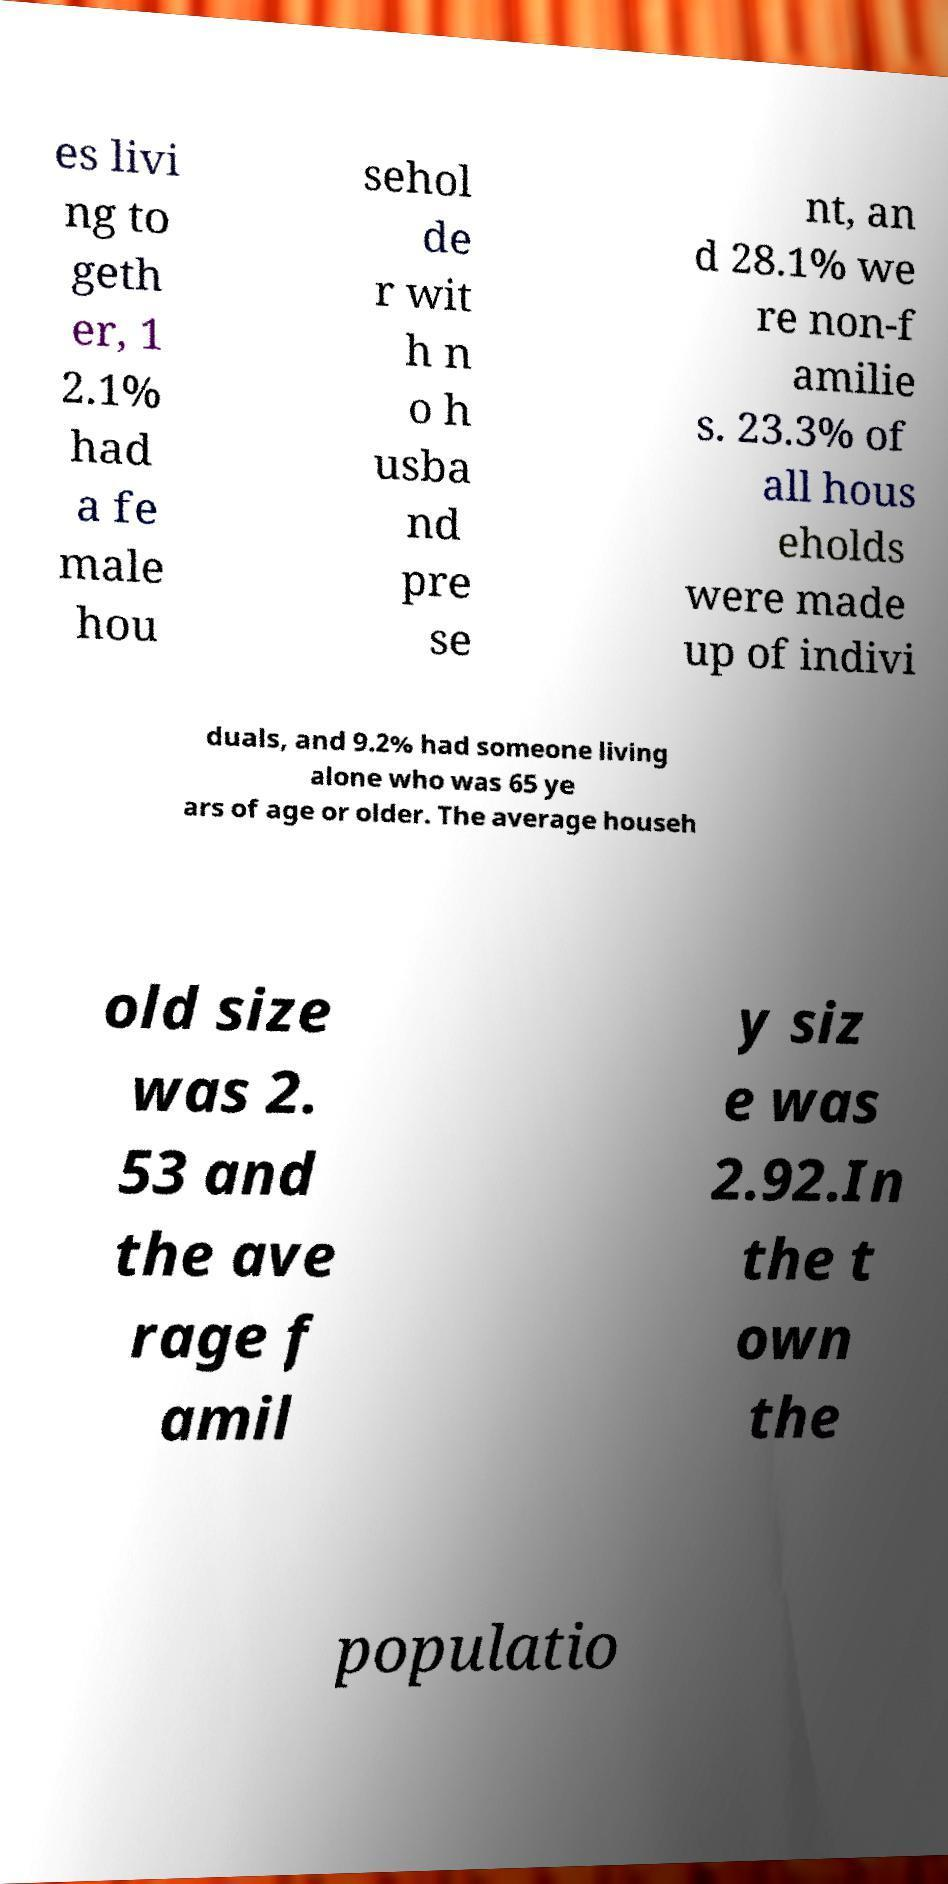There's text embedded in this image that I need extracted. Can you transcribe it verbatim? es livi ng to geth er, 1 2.1% had a fe male hou sehol de r wit h n o h usba nd pre se nt, an d 28.1% we re non-f amilie s. 23.3% of all hous eholds were made up of indivi duals, and 9.2% had someone living alone who was 65 ye ars of age or older. The average househ old size was 2. 53 and the ave rage f amil y siz e was 2.92.In the t own the populatio 